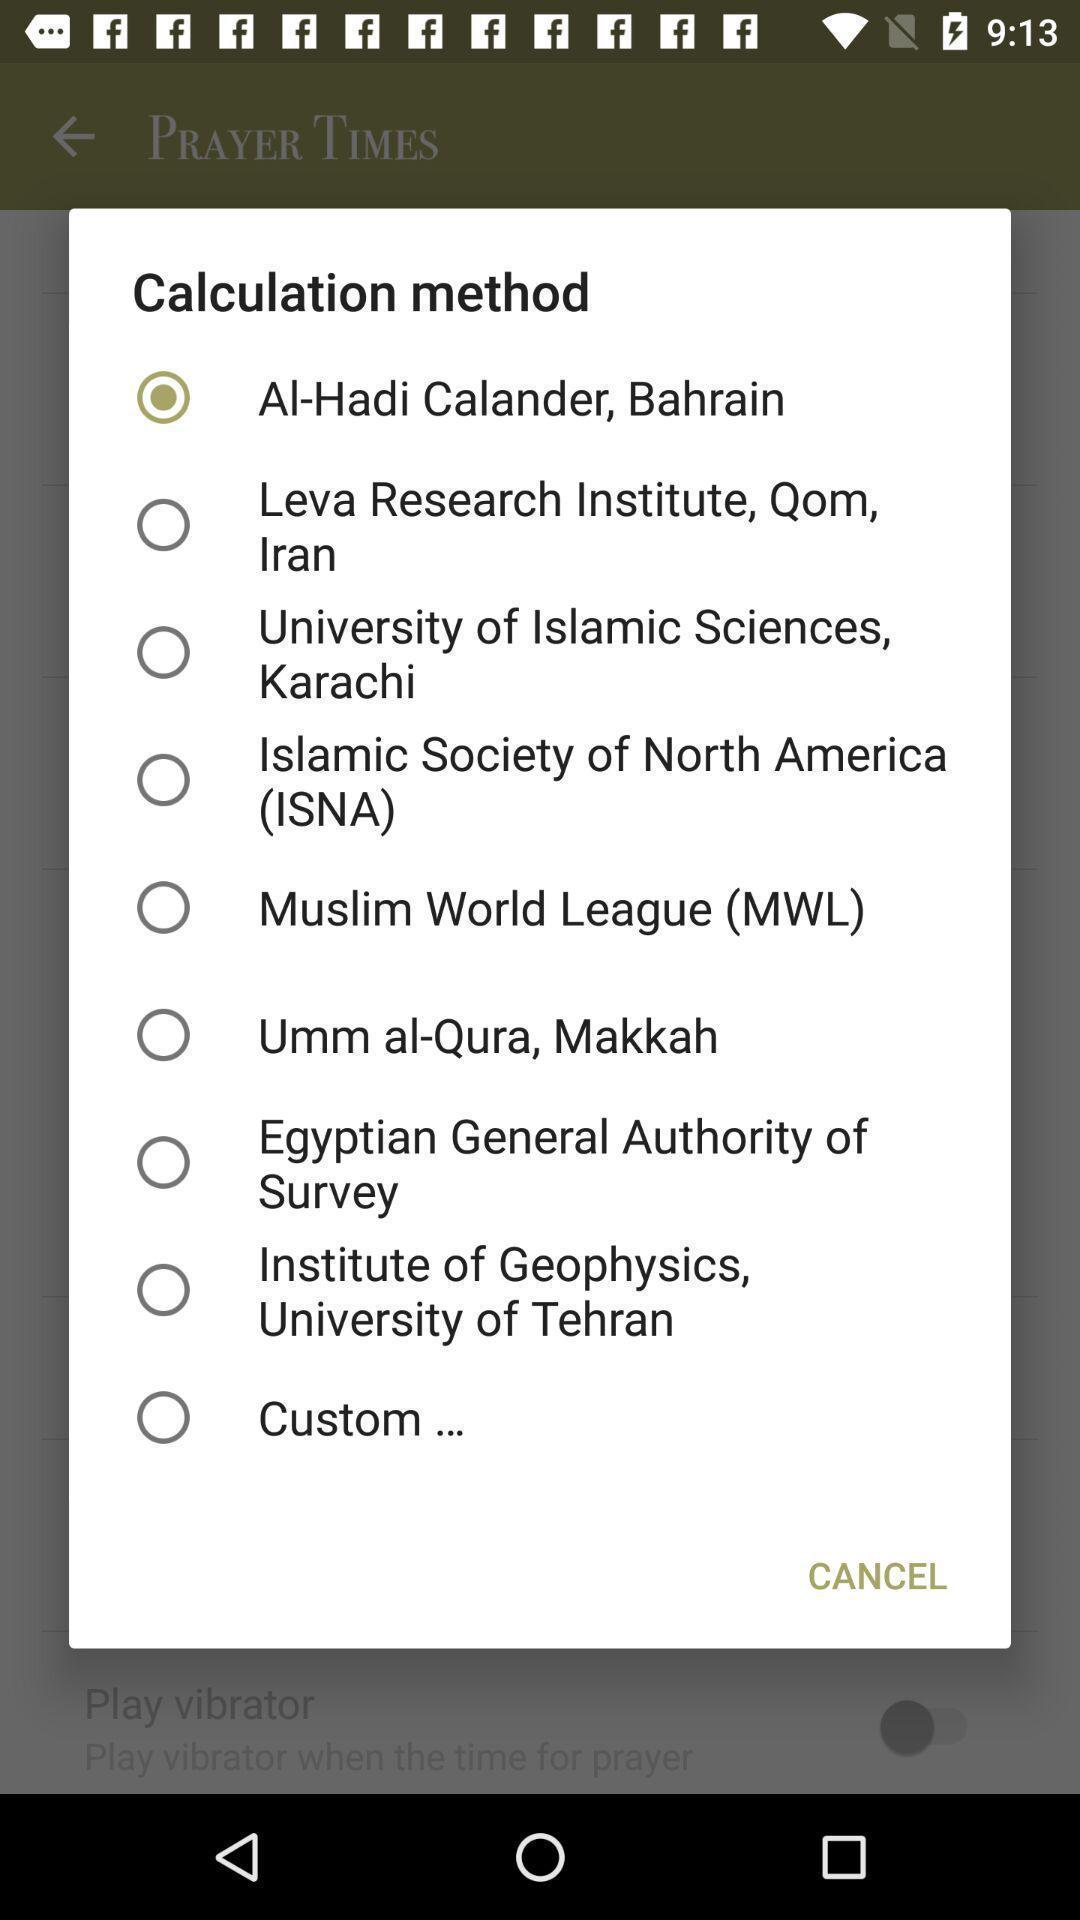Summarize the main components in this picture. Pop-up with options in a religion services related app. 